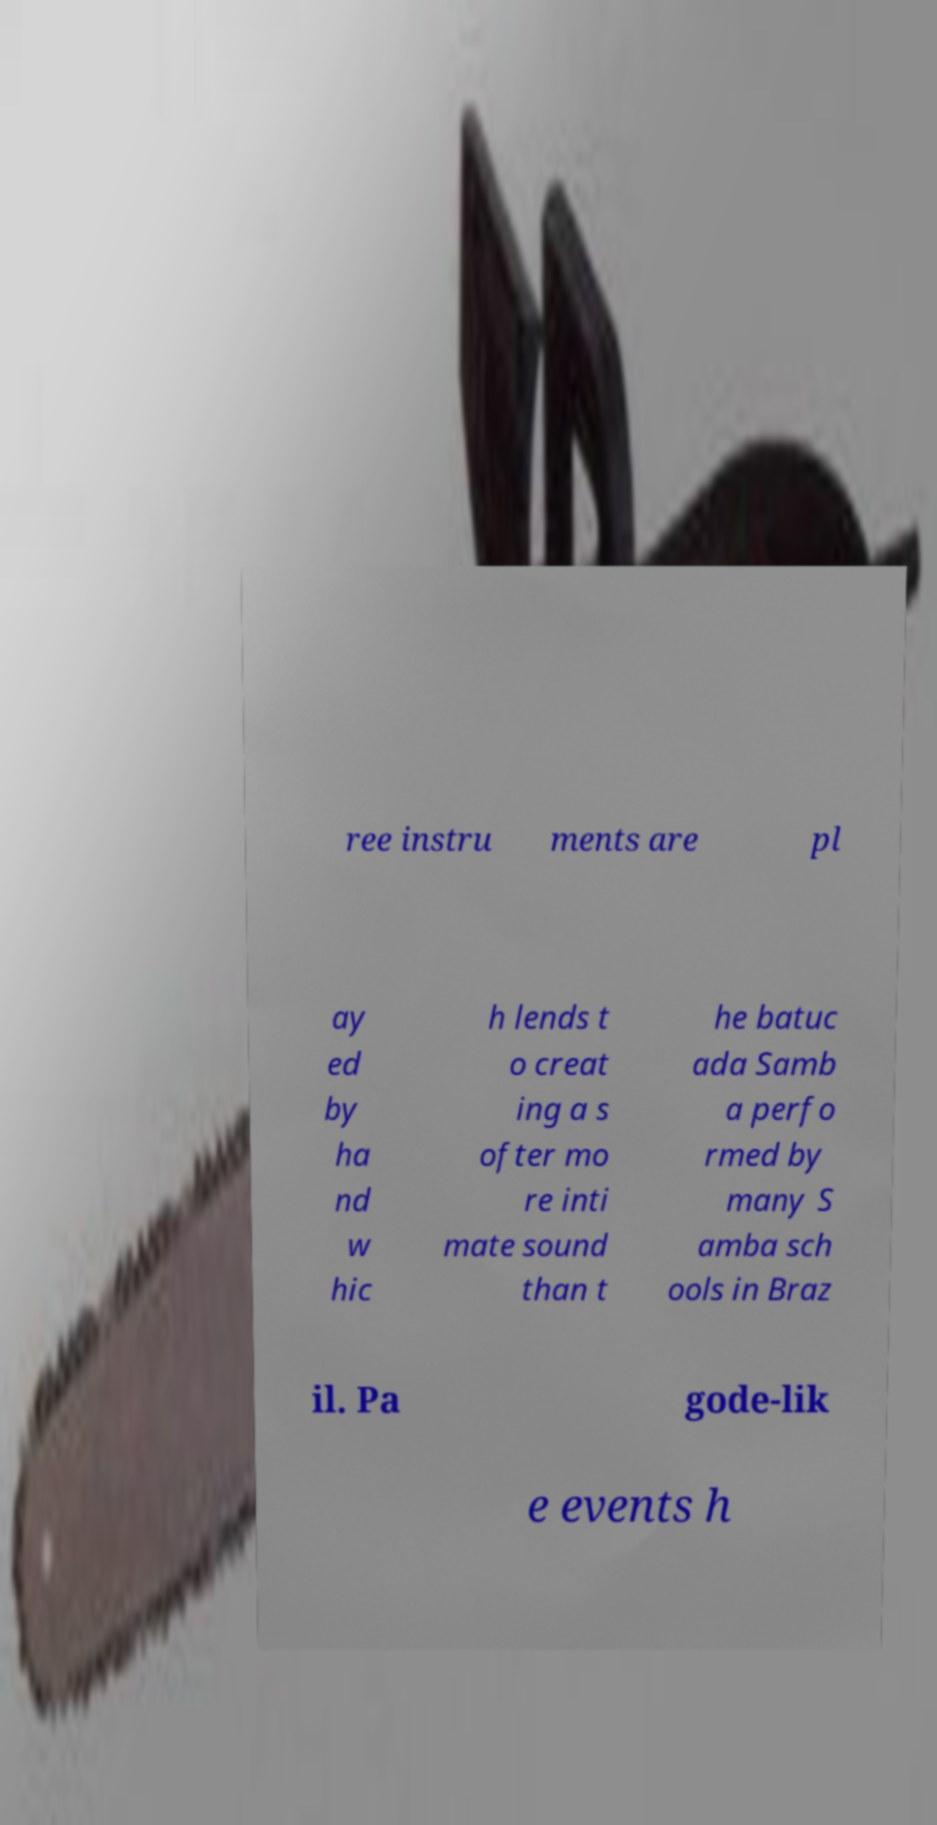Please identify and transcribe the text found in this image. ree instru ments are pl ay ed by ha nd w hic h lends t o creat ing a s ofter mo re inti mate sound than t he batuc ada Samb a perfo rmed by many S amba sch ools in Braz il. Pa gode-lik e events h 